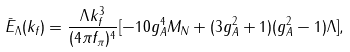Convert formula to latex. <formula><loc_0><loc_0><loc_500><loc_500>\bar { E } _ { \Lambda } ( k _ { f } ) = \frac { \Lambda k ^ { 3 } _ { f } } { ( 4 \pi f _ { \pi } ) ^ { 4 } } [ - 1 0 g ^ { 4 } _ { A } M _ { N } + ( 3 g ^ { 2 } _ { A } + 1 ) ( g ^ { 2 } _ { A } - 1 ) \Lambda ] ,</formula> 